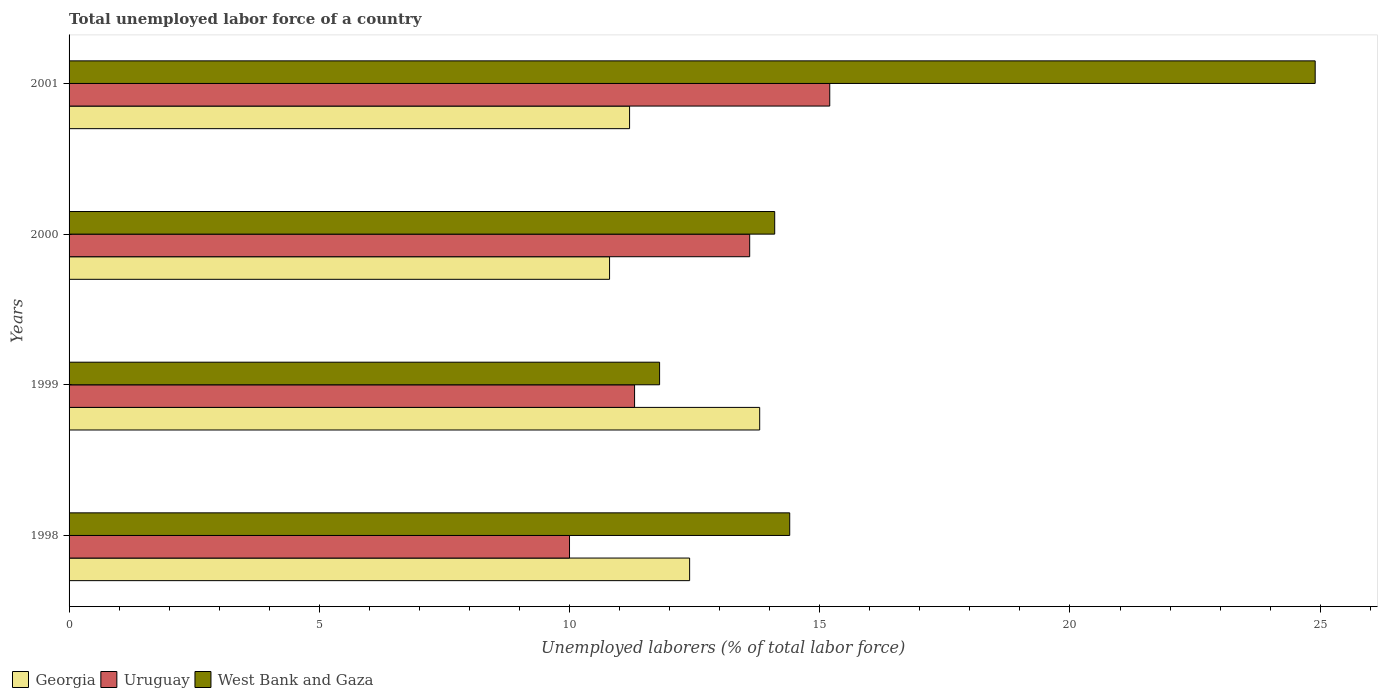How many bars are there on the 1st tick from the bottom?
Your response must be concise. 3. In how many cases, is the number of bars for a given year not equal to the number of legend labels?
Provide a succinct answer. 0. What is the total unemployed labor force in Uruguay in 2000?
Provide a succinct answer. 13.6. Across all years, what is the maximum total unemployed labor force in West Bank and Gaza?
Provide a short and direct response. 24.9. Across all years, what is the minimum total unemployed labor force in West Bank and Gaza?
Ensure brevity in your answer.  11.8. In which year was the total unemployed labor force in Georgia minimum?
Ensure brevity in your answer.  2000. What is the total total unemployed labor force in West Bank and Gaza in the graph?
Ensure brevity in your answer.  65.2. What is the difference between the total unemployed labor force in West Bank and Gaza in 1998 and that in 2000?
Offer a terse response. 0.3. What is the difference between the total unemployed labor force in Uruguay in 2000 and the total unemployed labor force in Georgia in 2001?
Make the answer very short. 2.4. What is the average total unemployed labor force in Georgia per year?
Give a very brief answer. 12.05. In the year 2000, what is the difference between the total unemployed labor force in West Bank and Gaza and total unemployed labor force in Georgia?
Offer a terse response. 3.3. What is the ratio of the total unemployed labor force in Uruguay in 1999 to that in 2000?
Your response must be concise. 0.83. Is the difference between the total unemployed labor force in West Bank and Gaza in 1998 and 2000 greater than the difference between the total unemployed labor force in Georgia in 1998 and 2000?
Offer a terse response. No. What is the difference between the highest and the second highest total unemployed labor force in West Bank and Gaza?
Provide a short and direct response. 10.5. What is the difference between the highest and the lowest total unemployed labor force in West Bank and Gaza?
Offer a terse response. 13.1. In how many years, is the total unemployed labor force in Uruguay greater than the average total unemployed labor force in Uruguay taken over all years?
Make the answer very short. 2. Is the sum of the total unemployed labor force in Uruguay in 1999 and 2000 greater than the maximum total unemployed labor force in Georgia across all years?
Make the answer very short. Yes. What does the 3rd bar from the top in 1999 represents?
Give a very brief answer. Georgia. What does the 1st bar from the bottom in 2001 represents?
Offer a terse response. Georgia. How many bars are there?
Ensure brevity in your answer.  12. Are all the bars in the graph horizontal?
Give a very brief answer. Yes. What is the difference between two consecutive major ticks on the X-axis?
Make the answer very short. 5. How many legend labels are there?
Your answer should be very brief. 3. How are the legend labels stacked?
Offer a terse response. Horizontal. What is the title of the graph?
Provide a succinct answer. Total unemployed labor force of a country. Does "Chile" appear as one of the legend labels in the graph?
Give a very brief answer. No. What is the label or title of the X-axis?
Ensure brevity in your answer.  Unemployed laborers (% of total labor force). What is the label or title of the Y-axis?
Provide a succinct answer. Years. What is the Unemployed laborers (% of total labor force) in Georgia in 1998?
Provide a short and direct response. 12.4. What is the Unemployed laborers (% of total labor force) in West Bank and Gaza in 1998?
Your answer should be compact. 14.4. What is the Unemployed laborers (% of total labor force) in Georgia in 1999?
Your response must be concise. 13.8. What is the Unemployed laborers (% of total labor force) in Uruguay in 1999?
Make the answer very short. 11.3. What is the Unemployed laborers (% of total labor force) of West Bank and Gaza in 1999?
Ensure brevity in your answer.  11.8. What is the Unemployed laborers (% of total labor force) of Georgia in 2000?
Ensure brevity in your answer.  10.8. What is the Unemployed laborers (% of total labor force) of Uruguay in 2000?
Make the answer very short. 13.6. What is the Unemployed laborers (% of total labor force) in West Bank and Gaza in 2000?
Provide a short and direct response. 14.1. What is the Unemployed laborers (% of total labor force) of Georgia in 2001?
Your answer should be very brief. 11.2. What is the Unemployed laborers (% of total labor force) in Uruguay in 2001?
Your response must be concise. 15.2. What is the Unemployed laborers (% of total labor force) in West Bank and Gaza in 2001?
Your response must be concise. 24.9. Across all years, what is the maximum Unemployed laborers (% of total labor force) in Georgia?
Your response must be concise. 13.8. Across all years, what is the maximum Unemployed laborers (% of total labor force) in Uruguay?
Provide a short and direct response. 15.2. Across all years, what is the maximum Unemployed laborers (% of total labor force) of West Bank and Gaza?
Provide a succinct answer. 24.9. Across all years, what is the minimum Unemployed laborers (% of total labor force) in Georgia?
Offer a terse response. 10.8. Across all years, what is the minimum Unemployed laborers (% of total labor force) in West Bank and Gaza?
Keep it short and to the point. 11.8. What is the total Unemployed laborers (% of total labor force) in Georgia in the graph?
Your response must be concise. 48.2. What is the total Unemployed laborers (% of total labor force) of Uruguay in the graph?
Offer a terse response. 50.1. What is the total Unemployed laborers (% of total labor force) of West Bank and Gaza in the graph?
Provide a succinct answer. 65.2. What is the difference between the Unemployed laborers (% of total labor force) of Uruguay in 1998 and that in 1999?
Ensure brevity in your answer.  -1.3. What is the difference between the Unemployed laborers (% of total labor force) in West Bank and Gaza in 1998 and that in 1999?
Give a very brief answer. 2.6. What is the difference between the Unemployed laborers (% of total labor force) of Georgia in 1998 and that in 2000?
Offer a terse response. 1.6. What is the difference between the Unemployed laborers (% of total labor force) in Uruguay in 1998 and that in 2000?
Your response must be concise. -3.6. What is the difference between the Unemployed laborers (% of total labor force) of West Bank and Gaza in 1998 and that in 2000?
Your answer should be compact. 0.3. What is the difference between the Unemployed laborers (% of total labor force) in Uruguay in 1998 and that in 2001?
Provide a short and direct response. -5.2. What is the difference between the Unemployed laborers (% of total labor force) of West Bank and Gaza in 1998 and that in 2001?
Keep it short and to the point. -10.5. What is the difference between the Unemployed laborers (% of total labor force) of Georgia in 1999 and that in 2000?
Your response must be concise. 3. What is the difference between the Unemployed laborers (% of total labor force) of Uruguay in 1999 and that in 2000?
Make the answer very short. -2.3. What is the difference between the Unemployed laborers (% of total labor force) in West Bank and Gaza in 1999 and that in 2000?
Offer a terse response. -2.3. What is the difference between the Unemployed laborers (% of total labor force) of Georgia in 2000 and that in 2001?
Offer a terse response. -0.4. What is the difference between the Unemployed laborers (% of total labor force) of Uruguay in 2000 and that in 2001?
Keep it short and to the point. -1.6. What is the difference between the Unemployed laborers (% of total labor force) of Georgia in 1998 and the Unemployed laborers (% of total labor force) of Uruguay in 1999?
Offer a very short reply. 1.1. What is the difference between the Unemployed laborers (% of total labor force) in Georgia in 1998 and the Unemployed laborers (% of total labor force) in West Bank and Gaza in 1999?
Give a very brief answer. 0.6. What is the difference between the Unemployed laborers (% of total labor force) of Uruguay in 1998 and the Unemployed laborers (% of total labor force) of West Bank and Gaza in 1999?
Give a very brief answer. -1.8. What is the difference between the Unemployed laborers (% of total labor force) in Georgia in 1998 and the Unemployed laborers (% of total labor force) in Uruguay in 2001?
Ensure brevity in your answer.  -2.8. What is the difference between the Unemployed laborers (% of total labor force) in Uruguay in 1998 and the Unemployed laborers (% of total labor force) in West Bank and Gaza in 2001?
Your response must be concise. -14.9. What is the difference between the Unemployed laborers (% of total labor force) of Georgia in 1999 and the Unemployed laborers (% of total labor force) of Uruguay in 2001?
Keep it short and to the point. -1.4. What is the difference between the Unemployed laborers (% of total labor force) of Georgia in 1999 and the Unemployed laborers (% of total labor force) of West Bank and Gaza in 2001?
Give a very brief answer. -11.1. What is the difference between the Unemployed laborers (% of total labor force) of Georgia in 2000 and the Unemployed laborers (% of total labor force) of Uruguay in 2001?
Give a very brief answer. -4.4. What is the difference between the Unemployed laborers (% of total labor force) of Georgia in 2000 and the Unemployed laborers (% of total labor force) of West Bank and Gaza in 2001?
Ensure brevity in your answer.  -14.1. What is the average Unemployed laborers (% of total labor force) of Georgia per year?
Ensure brevity in your answer.  12.05. What is the average Unemployed laborers (% of total labor force) of Uruguay per year?
Offer a terse response. 12.53. In the year 1998, what is the difference between the Unemployed laborers (% of total labor force) of Georgia and Unemployed laborers (% of total labor force) of West Bank and Gaza?
Your response must be concise. -2. In the year 1998, what is the difference between the Unemployed laborers (% of total labor force) in Uruguay and Unemployed laborers (% of total labor force) in West Bank and Gaza?
Your answer should be compact. -4.4. In the year 1999, what is the difference between the Unemployed laborers (% of total labor force) in Georgia and Unemployed laborers (% of total labor force) in Uruguay?
Your answer should be very brief. 2.5. In the year 1999, what is the difference between the Unemployed laborers (% of total labor force) of Georgia and Unemployed laborers (% of total labor force) of West Bank and Gaza?
Offer a very short reply. 2. In the year 2000, what is the difference between the Unemployed laborers (% of total labor force) in Georgia and Unemployed laborers (% of total labor force) in Uruguay?
Provide a succinct answer. -2.8. In the year 2001, what is the difference between the Unemployed laborers (% of total labor force) in Georgia and Unemployed laborers (% of total labor force) in Uruguay?
Keep it short and to the point. -4. In the year 2001, what is the difference between the Unemployed laborers (% of total labor force) in Georgia and Unemployed laborers (% of total labor force) in West Bank and Gaza?
Make the answer very short. -13.7. In the year 2001, what is the difference between the Unemployed laborers (% of total labor force) of Uruguay and Unemployed laborers (% of total labor force) of West Bank and Gaza?
Your response must be concise. -9.7. What is the ratio of the Unemployed laborers (% of total labor force) of Georgia in 1998 to that in 1999?
Provide a succinct answer. 0.9. What is the ratio of the Unemployed laborers (% of total labor force) of Uruguay in 1998 to that in 1999?
Offer a very short reply. 0.89. What is the ratio of the Unemployed laborers (% of total labor force) of West Bank and Gaza in 1998 to that in 1999?
Your response must be concise. 1.22. What is the ratio of the Unemployed laborers (% of total labor force) in Georgia in 1998 to that in 2000?
Give a very brief answer. 1.15. What is the ratio of the Unemployed laborers (% of total labor force) of Uruguay in 1998 to that in 2000?
Your answer should be very brief. 0.74. What is the ratio of the Unemployed laborers (% of total labor force) of West Bank and Gaza in 1998 to that in 2000?
Your answer should be compact. 1.02. What is the ratio of the Unemployed laborers (% of total labor force) in Georgia in 1998 to that in 2001?
Your response must be concise. 1.11. What is the ratio of the Unemployed laborers (% of total labor force) of Uruguay in 1998 to that in 2001?
Ensure brevity in your answer.  0.66. What is the ratio of the Unemployed laborers (% of total labor force) of West Bank and Gaza in 1998 to that in 2001?
Ensure brevity in your answer.  0.58. What is the ratio of the Unemployed laborers (% of total labor force) of Georgia in 1999 to that in 2000?
Offer a very short reply. 1.28. What is the ratio of the Unemployed laborers (% of total labor force) of Uruguay in 1999 to that in 2000?
Offer a very short reply. 0.83. What is the ratio of the Unemployed laborers (% of total labor force) of West Bank and Gaza in 1999 to that in 2000?
Your response must be concise. 0.84. What is the ratio of the Unemployed laborers (% of total labor force) of Georgia in 1999 to that in 2001?
Keep it short and to the point. 1.23. What is the ratio of the Unemployed laborers (% of total labor force) in Uruguay in 1999 to that in 2001?
Give a very brief answer. 0.74. What is the ratio of the Unemployed laborers (% of total labor force) in West Bank and Gaza in 1999 to that in 2001?
Your response must be concise. 0.47. What is the ratio of the Unemployed laborers (% of total labor force) of Uruguay in 2000 to that in 2001?
Offer a terse response. 0.89. What is the ratio of the Unemployed laborers (% of total labor force) of West Bank and Gaza in 2000 to that in 2001?
Ensure brevity in your answer.  0.57. What is the difference between the highest and the second highest Unemployed laborers (% of total labor force) of Georgia?
Ensure brevity in your answer.  1.4. What is the difference between the highest and the second highest Unemployed laborers (% of total labor force) in Uruguay?
Give a very brief answer. 1.6. What is the difference between the highest and the lowest Unemployed laborers (% of total labor force) in Georgia?
Keep it short and to the point. 3. 